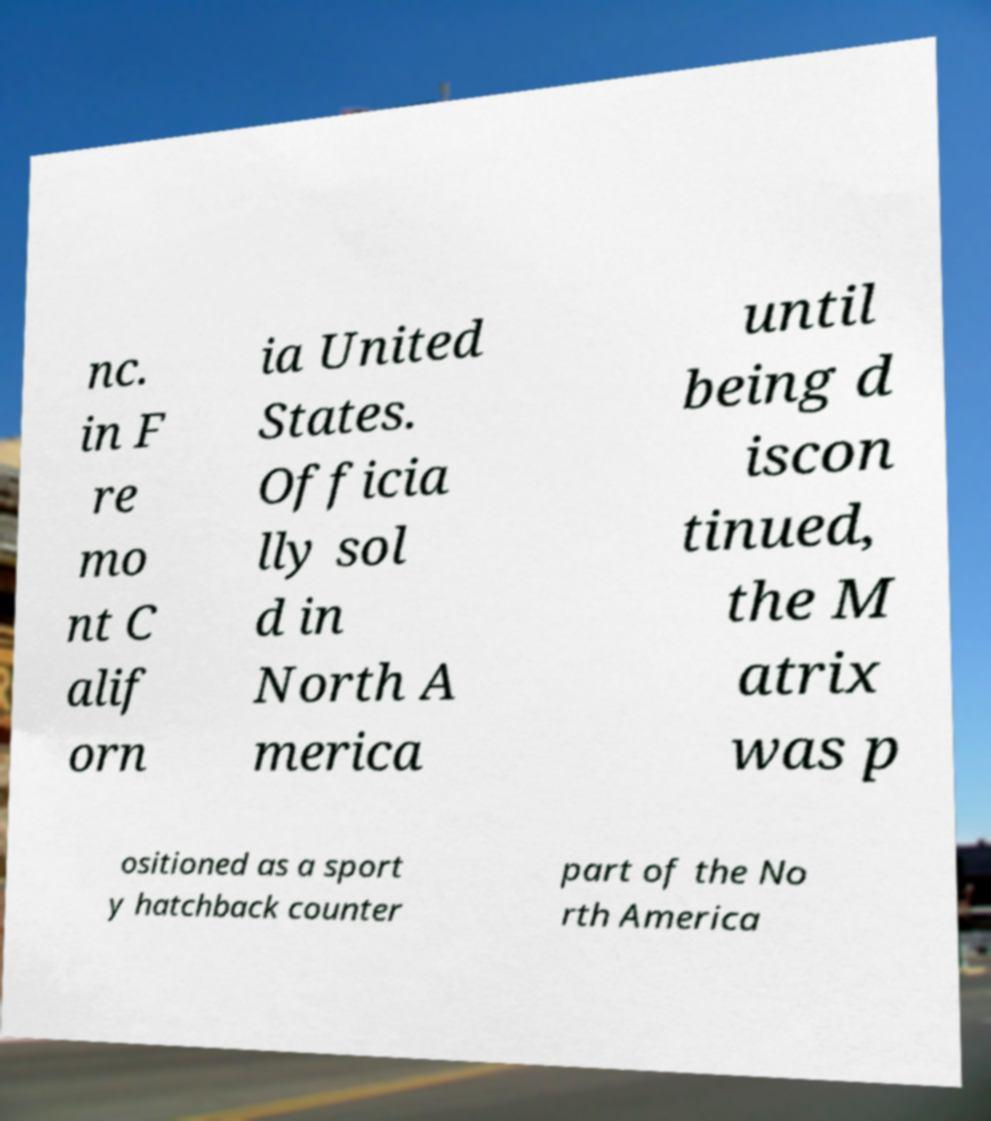Please identify and transcribe the text found in this image. nc. in F re mo nt C alif orn ia United States. Officia lly sol d in North A merica until being d iscon tinued, the M atrix was p ositioned as a sport y hatchback counter part of the No rth America 